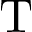<formula> <loc_0><loc_0><loc_500><loc_500>T</formula> 